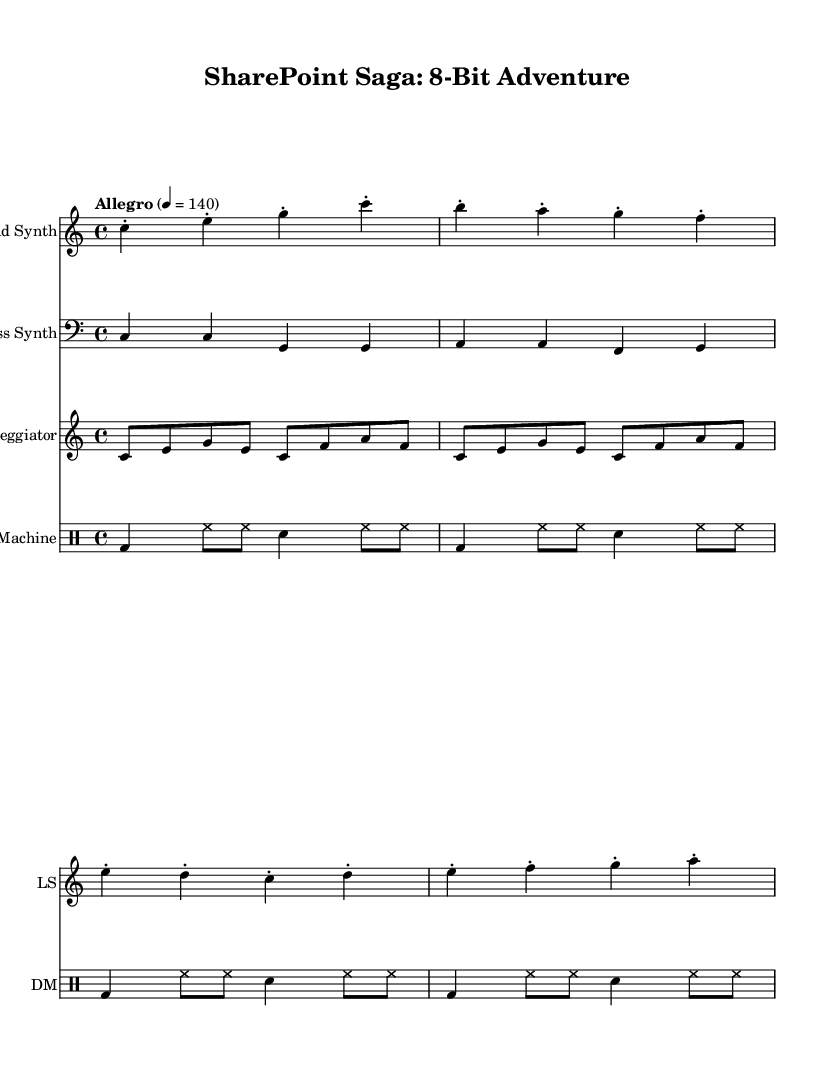What is the key signature of this music? The key signature is C major, which contains no sharps or flats, as indicated at the beginning of the score where the key is explicitly labeled.
Answer: C major What is the time signature of this music? The time signature is 4/4, meaning there are four beats per measure and the quarter note gets one beat. This is evident from the "4/4" indicated in the global section of the code.
Answer: 4/4 What is the tempo marking for this piece? The tempo marking is "Allegro" at a speed of 140 beats per minute, which is specified in the global section and indicates a fast and lively pace.
Answer: Allegro 4 = 140 How many repetitions does the arpeggiator play? The arpeggiator part is marked with a "repeat unfold 2" directive, meaning it will play the specified sequence two times consecutively, as indicated in the code.
Answer: 2 Which instrument has a bass clef? The bass part utilizes a bass clef, which is standard for lower-pitched instruments, as shown in the score where bassSynth is defined with a clef bass statement.
Answer: Bass Synth What type of rhythm pattern does the drum machine use? The drum machine uses a combination of bass drum, hi-hat, and snare patterns. The notation inside the drum mode indicates specific rhythms for these pieces.
Answer: Bass drum, hi-hat, snare What instrument plays the lead melody? The lead melody is played by the "Lead Synth," which is designated in the score with the appropriate synth line above the bass and arpeggiator parts.
Answer: Lead Synth 